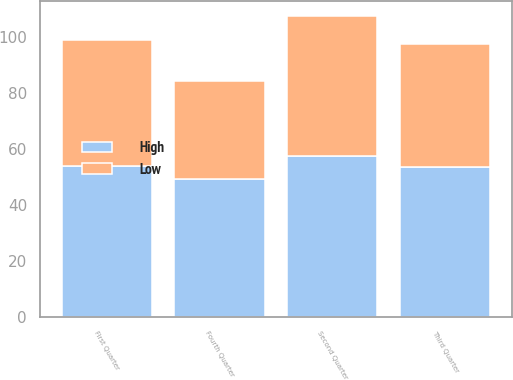Convert chart. <chart><loc_0><loc_0><loc_500><loc_500><stacked_bar_chart><ecel><fcel>First Quarter<fcel>Second Quarter<fcel>Third Quarter<fcel>Fourth Quarter<nl><fcel>High<fcel>54.16<fcel>57.7<fcel>53.55<fcel>49.25<nl><fcel>Low<fcel>44.87<fcel>49.91<fcel>44.2<fcel>35.29<nl></chart> 